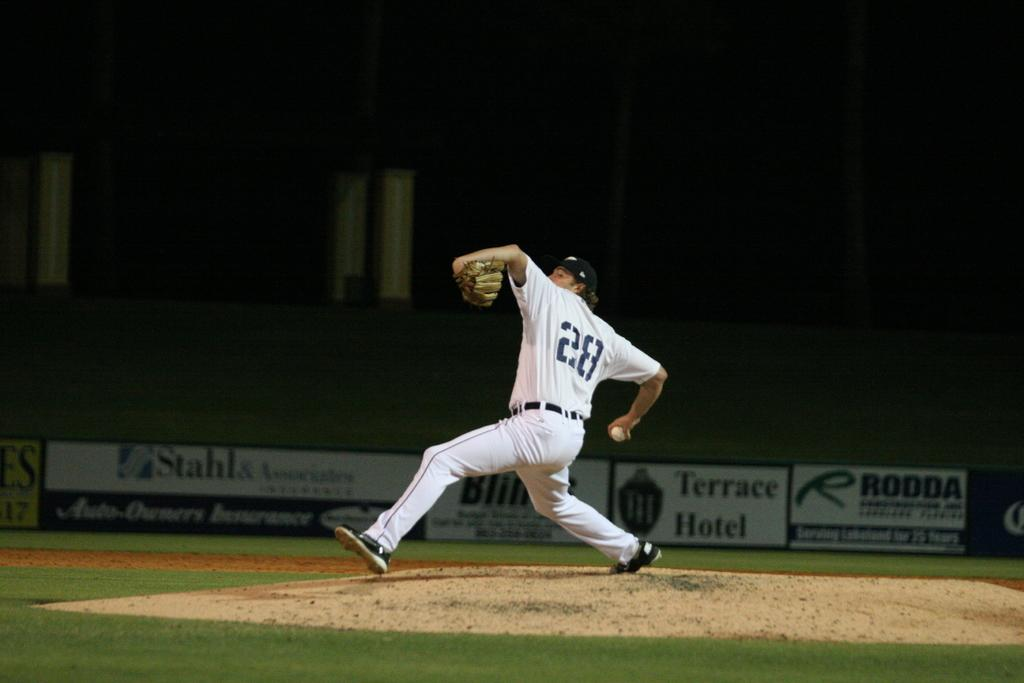Provide a one-sentence caption for the provided image. Baseball player wearing number 28 throwing a pitch. 